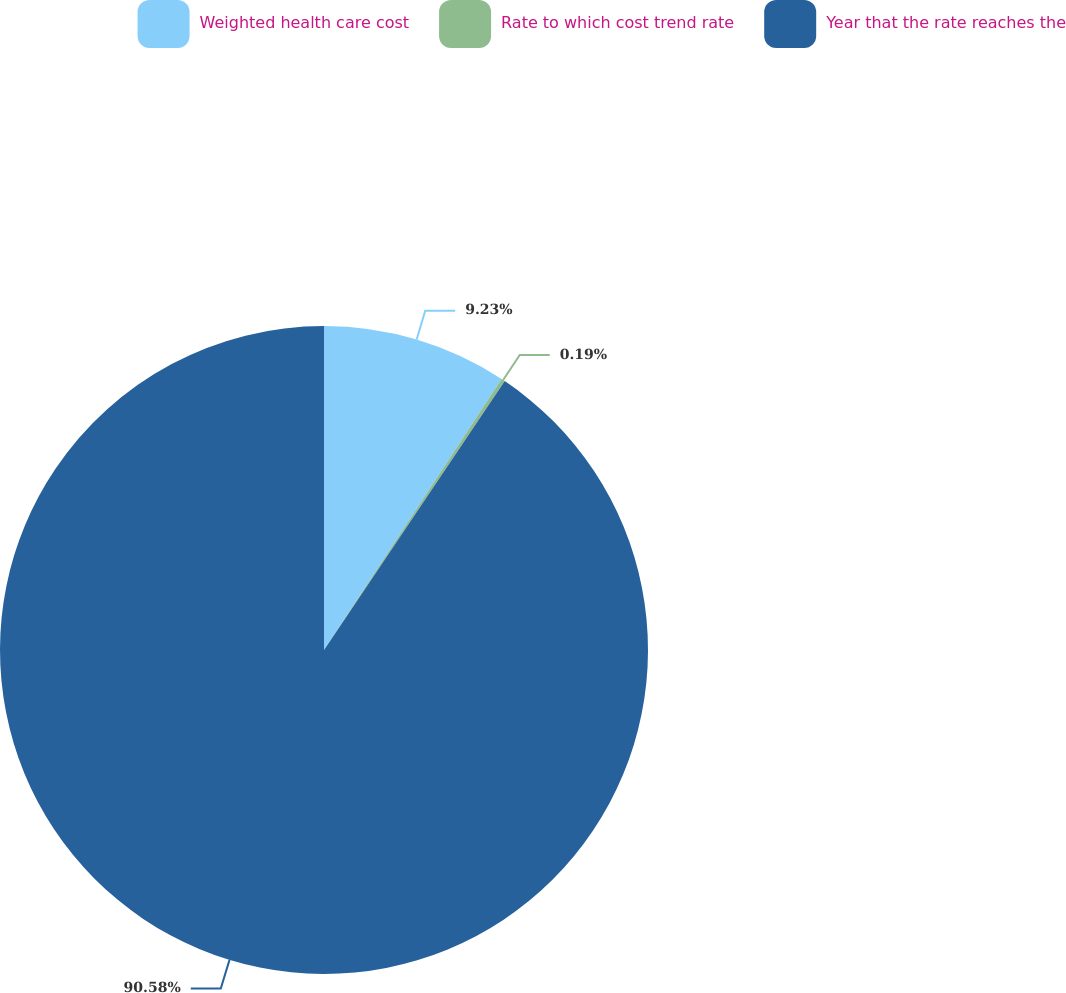Convert chart to OTSL. <chart><loc_0><loc_0><loc_500><loc_500><pie_chart><fcel>Weighted health care cost<fcel>Rate to which cost trend rate<fcel>Year that the rate reaches the<nl><fcel>9.23%<fcel>0.19%<fcel>90.58%<nl></chart> 